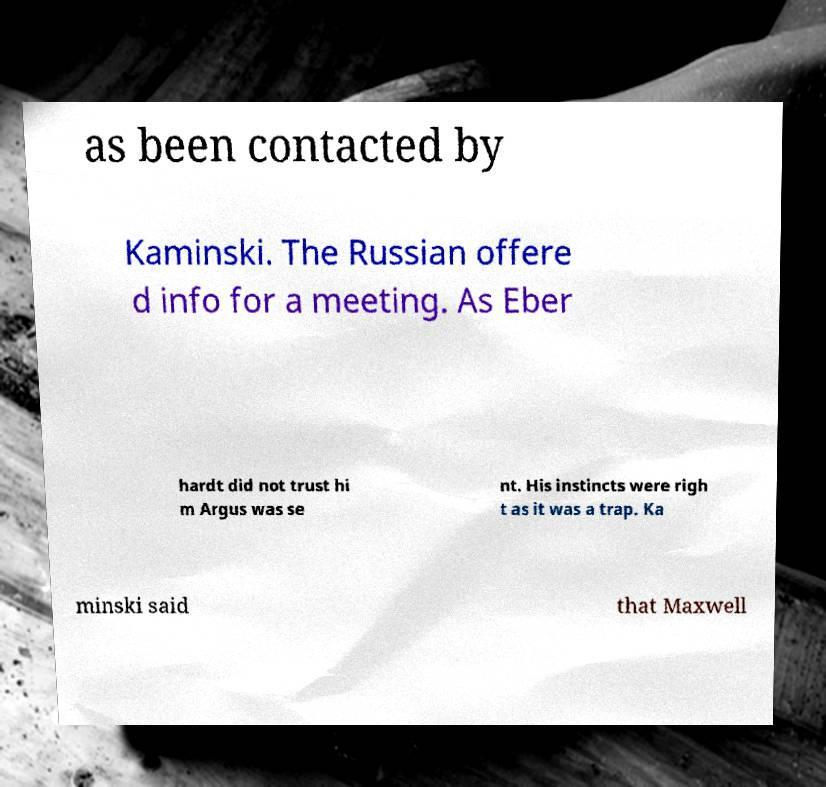Please read and relay the text visible in this image. What does it say? as been contacted by Kaminski. The Russian offere d info for a meeting. As Eber hardt did not trust hi m Argus was se nt. His instincts were righ t as it was a trap. Ka minski said that Maxwell 